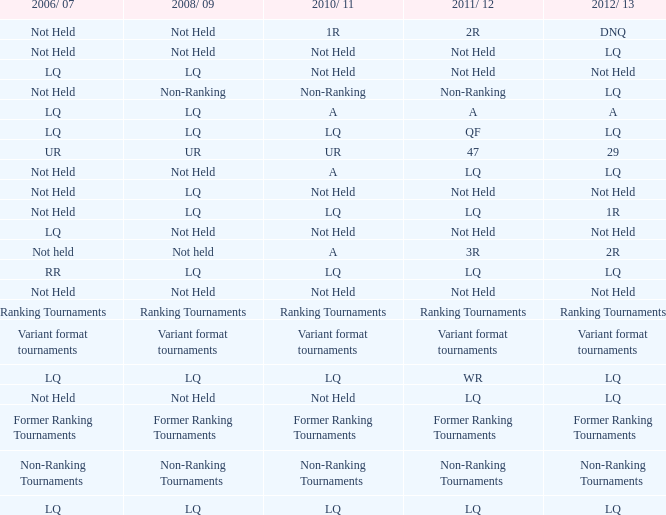What is 2008/09, when 2010/11 is UR? UR. 